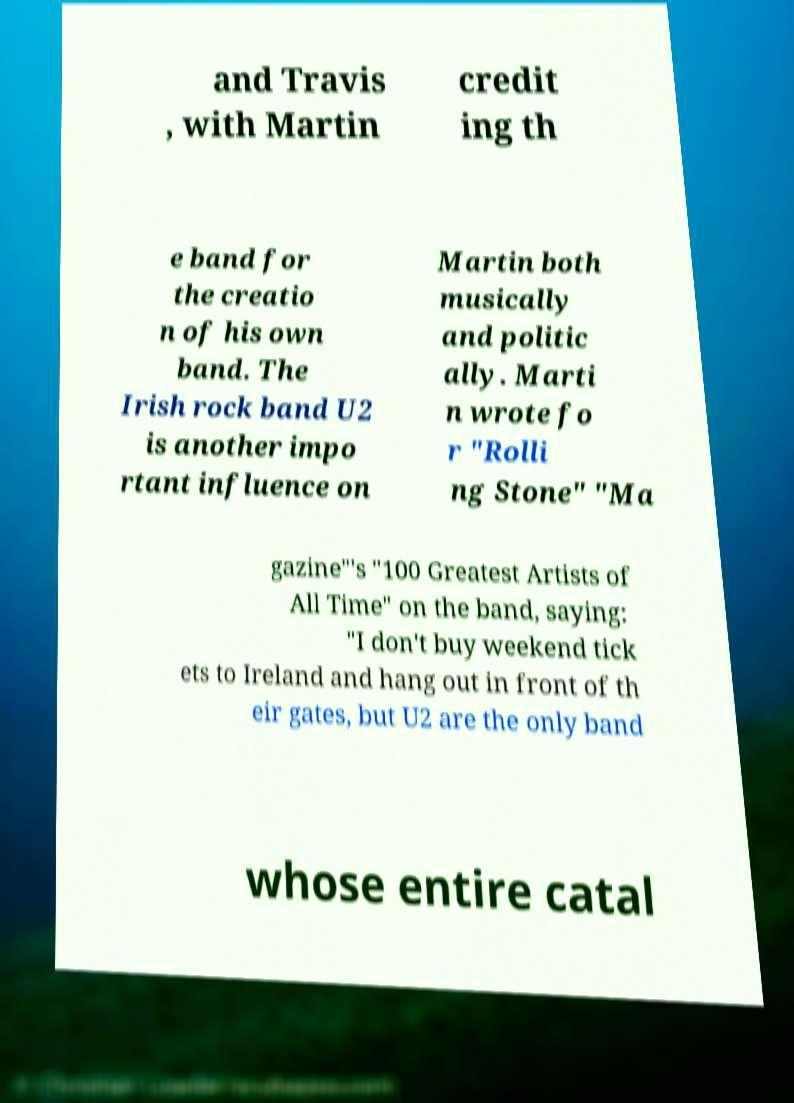There's text embedded in this image that I need extracted. Can you transcribe it verbatim? and Travis , with Martin credit ing th e band for the creatio n of his own band. The Irish rock band U2 is another impo rtant influence on Martin both musically and politic ally. Marti n wrote fo r "Rolli ng Stone" "Ma gazine"'s "100 Greatest Artists of All Time" on the band, saying: "I don't buy weekend tick ets to Ireland and hang out in front of th eir gates, but U2 are the only band whose entire catal 